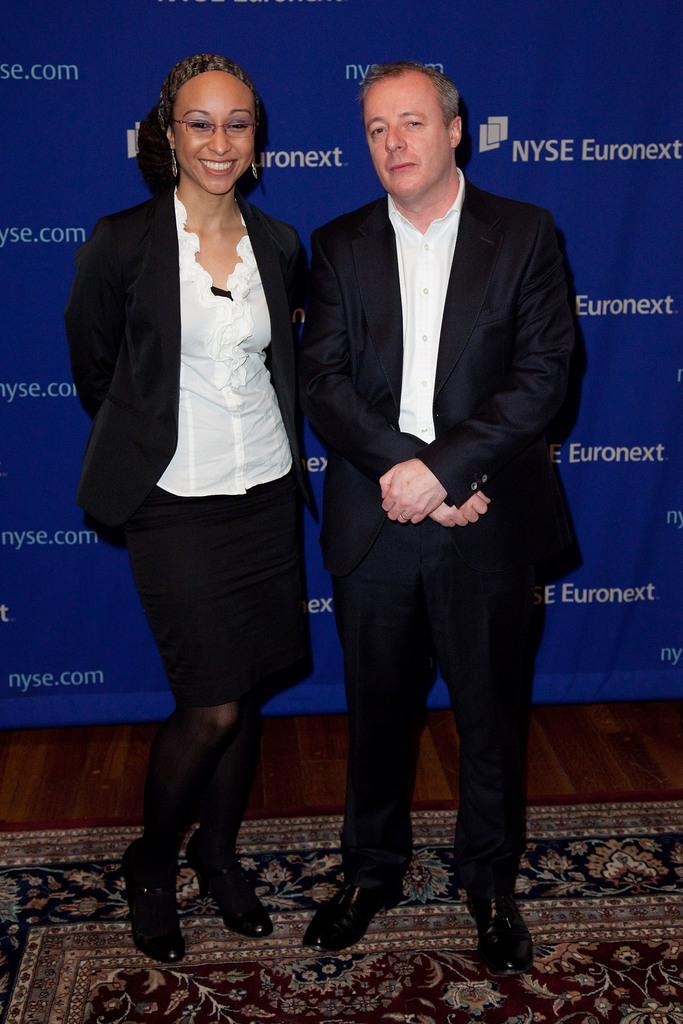How many people are present in the image? There are two people standing in the image. Can you describe the woman in the image? There is a woman in the image, and she is smiling. What is on the ground in front of the people? There is a floor mat in the image. What can be seen in the background behind the people? There is a hoarding visible behind the people. Can you tell me how many boats are in the image? There are no boats present in the image. Is the woman swimming in the image? There is no indication of swimming in the image; the woman is standing on a floor mat. 